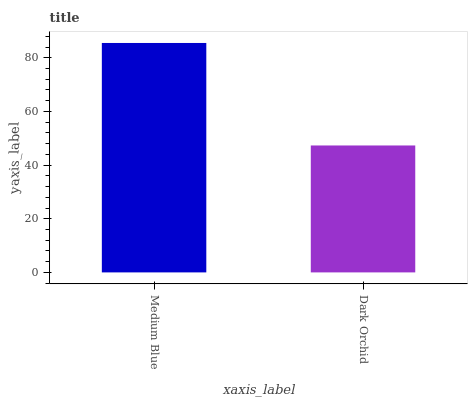Is Dark Orchid the maximum?
Answer yes or no. No. Is Medium Blue greater than Dark Orchid?
Answer yes or no. Yes. Is Dark Orchid less than Medium Blue?
Answer yes or no. Yes. Is Dark Orchid greater than Medium Blue?
Answer yes or no. No. Is Medium Blue less than Dark Orchid?
Answer yes or no. No. Is Medium Blue the high median?
Answer yes or no. Yes. Is Dark Orchid the low median?
Answer yes or no. Yes. Is Dark Orchid the high median?
Answer yes or no. No. Is Medium Blue the low median?
Answer yes or no. No. 